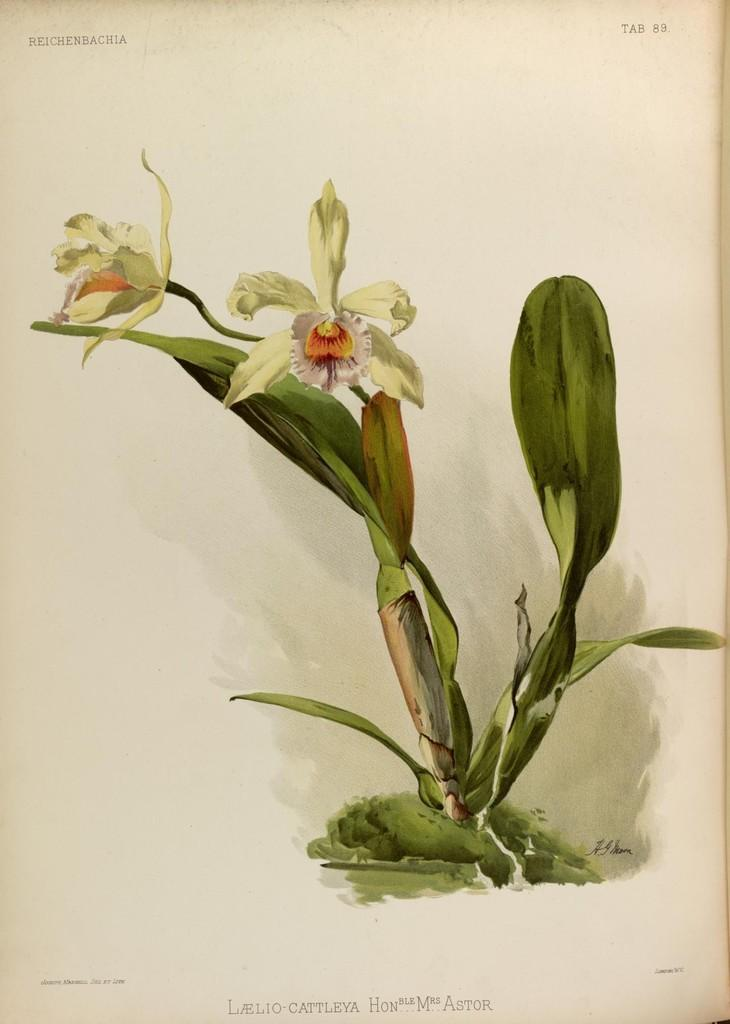What is depicted on the paper in the image? There is a drawing of a plant with flowers on the paper. What else can be seen on the paper besides the drawing? There are numbers and words on the paper. What type of mask is being worn by the plant in the image? There is no mask present in the image; it features a drawing of a plant with flowers. What type of dust can be seen on the numbers in the image? There is no dust present in the image; the numbers are clearly visible. 